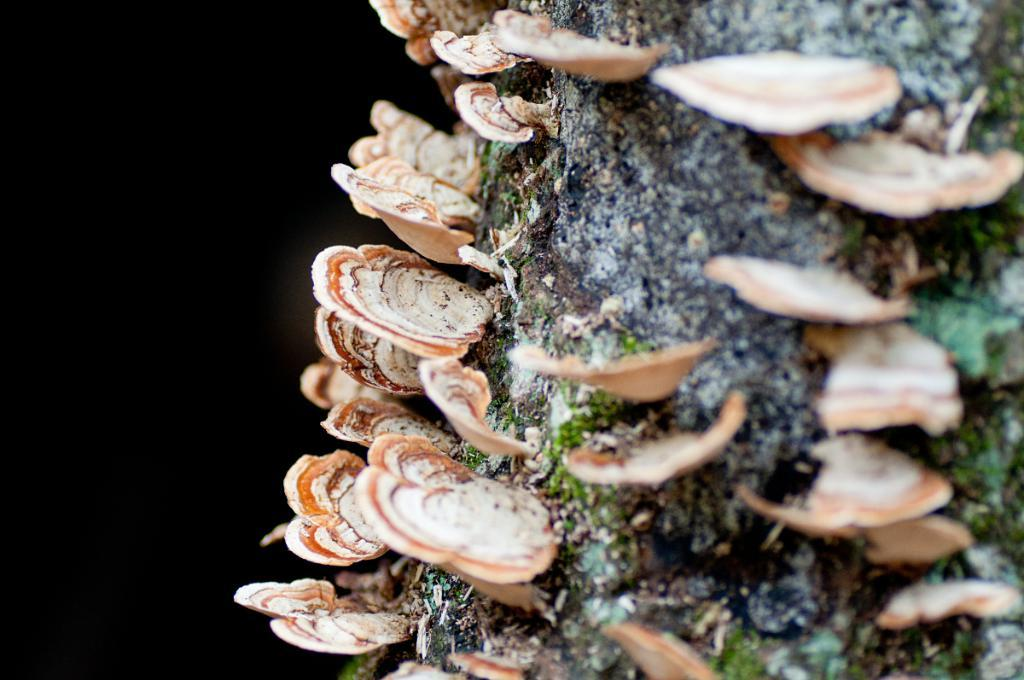What type of fungi can be seen in the image? There are polyporales on a wooden branch in the image. Can you describe the lighting on one side of the image? The left side of the image is dark. What type of peace symbol can be seen on the land in the image? There is no peace symbol or land present in the image; it features polyporales on a wooden branch with a dark left side. 